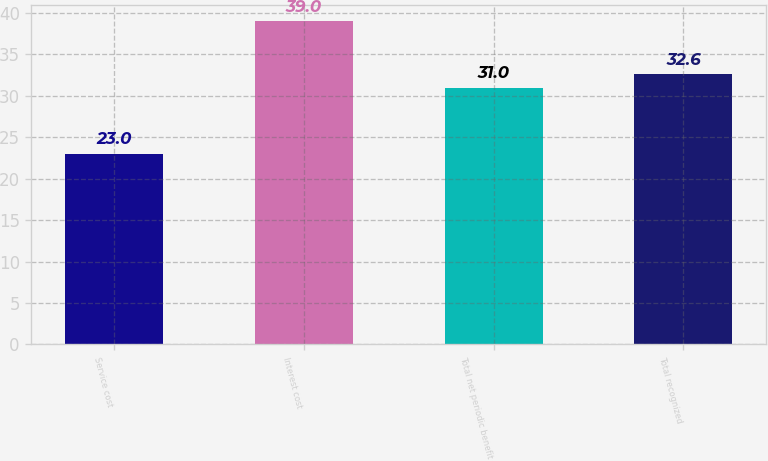<chart> <loc_0><loc_0><loc_500><loc_500><bar_chart><fcel>Service cost<fcel>Interest cost<fcel>Total net periodic benefit<fcel>Total recognized<nl><fcel>23<fcel>39<fcel>31<fcel>32.6<nl></chart> 